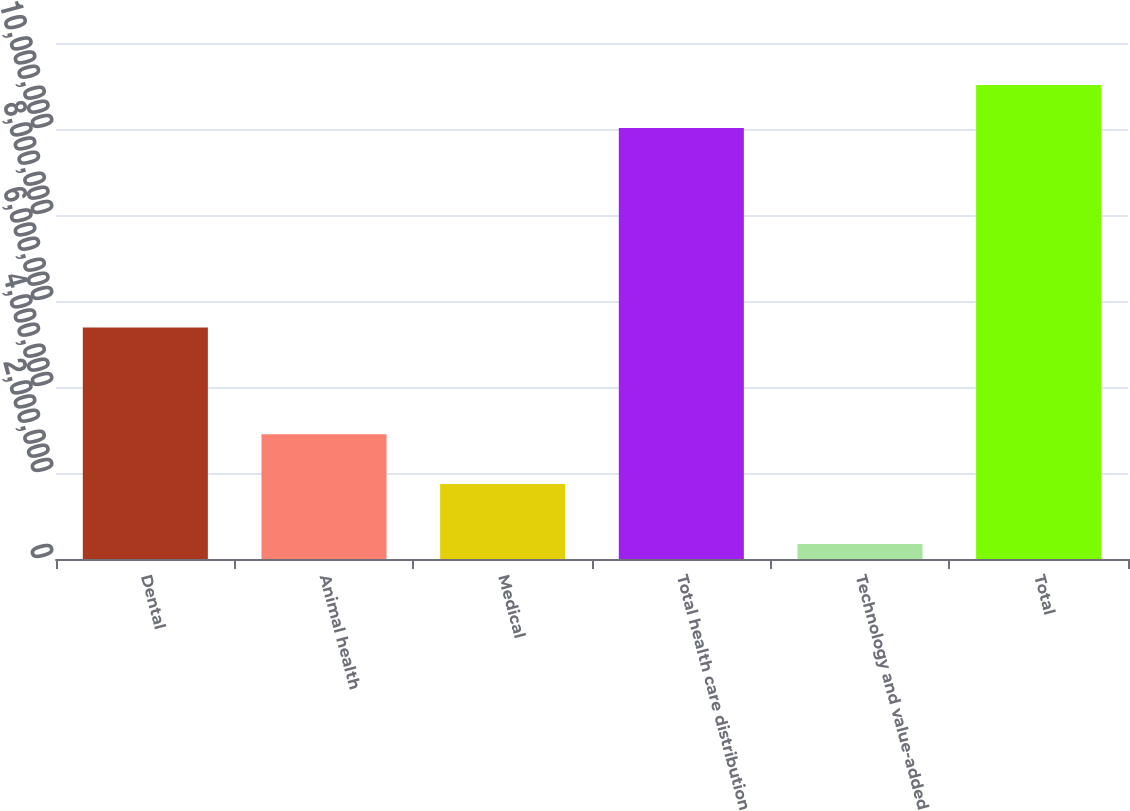Convert chart. <chart><loc_0><loc_0><loc_500><loc_500><bar_chart><fcel>Dental<fcel>Animal health<fcel>Medical<fcel>Total health care distribution<fcel>Technology and value-added<fcel>Total<nl><fcel>5.38122e+06<fcel>2.89861e+06<fcel>1.74268e+06<fcel>1.00225e+07<fcel>348878<fcel>1.10248e+07<nl></chart> 